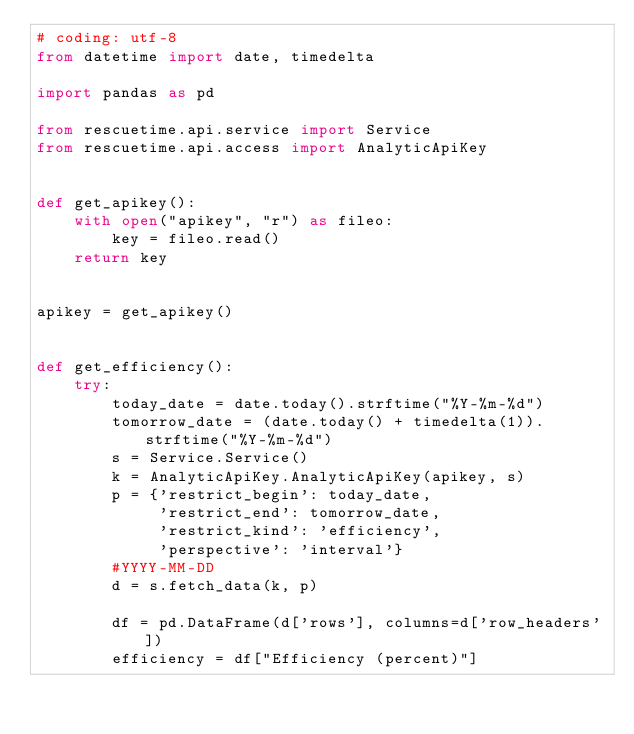<code> <loc_0><loc_0><loc_500><loc_500><_Python_># coding: utf-8
from datetime import date, timedelta

import pandas as pd

from rescuetime.api.service import Service
from rescuetime.api.access import AnalyticApiKey


def get_apikey():
    with open("apikey", "r") as fileo:
        key = fileo.read()
    return key


apikey = get_apikey()


def get_efficiency():
    try:
        today_date = date.today().strftime("%Y-%m-%d")
        tomorrow_date = (date.today() + timedelta(1)).strftime("%Y-%m-%d")
        s = Service.Service()
        k = AnalyticApiKey.AnalyticApiKey(apikey, s)
        p = {'restrict_begin': today_date,
             'restrict_end': tomorrow_date,
             'restrict_kind': 'efficiency',
             'perspective': 'interval'}
        #YYYY-MM-DD
        d = s.fetch_data(k, p)

        df = pd.DataFrame(d['rows'], columns=d['row_headers'])
        efficiency = df["Efficiency (percent)"]</code> 